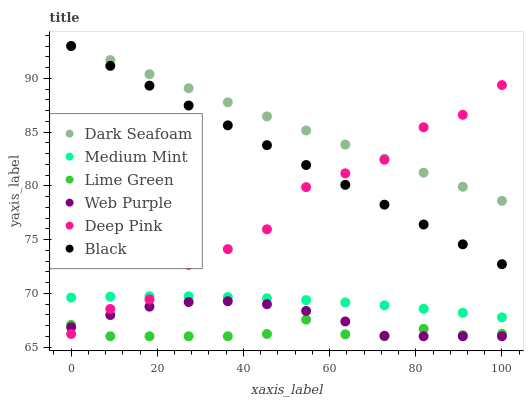Does Lime Green have the minimum area under the curve?
Answer yes or no. Yes. Does Dark Seafoam have the maximum area under the curve?
Answer yes or no. Yes. Does Deep Pink have the minimum area under the curve?
Answer yes or no. No. Does Deep Pink have the maximum area under the curve?
Answer yes or no. No. Is Black the smoothest?
Answer yes or no. Yes. Is Deep Pink the roughest?
Answer yes or no. Yes. Is Web Purple the smoothest?
Answer yes or no. No. Is Web Purple the roughest?
Answer yes or no. No. Does Web Purple have the lowest value?
Answer yes or no. Yes. Does Deep Pink have the lowest value?
Answer yes or no. No. Does Black have the highest value?
Answer yes or no. Yes. Does Deep Pink have the highest value?
Answer yes or no. No. Is Medium Mint less than Dark Seafoam?
Answer yes or no. Yes. Is Medium Mint greater than Lime Green?
Answer yes or no. Yes. Does Deep Pink intersect Lime Green?
Answer yes or no. Yes. Is Deep Pink less than Lime Green?
Answer yes or no. No. Is Deep Pink greater than Lime Green?
Answer yes or no. No. Does Medium Mint intersect Dark Seafoam?
Answer yes or no. No. 